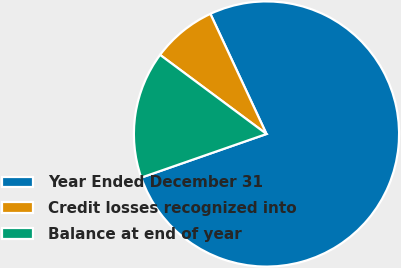<chart> <loc_0><loc_0><loc_500><loc_500><pie_chart><fcel>Year Ended December 31<fcel>Credit losses recognized into<fcel>Balance at end of year<nl><fcel>76.62%<fcel>7.87%<fcel>15.51%<nl></chart> 